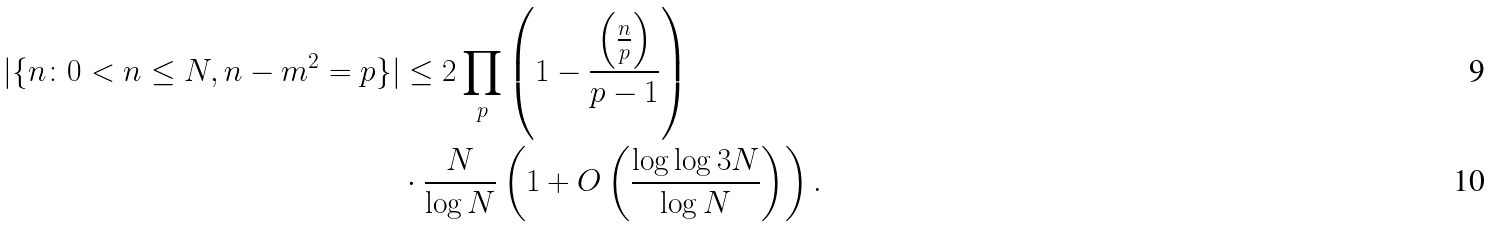Convert formula to latex. <formula><loc_0><loc_0><loc_500><loc_500>| \{ n \colon 0 < n \leq N , n - m ^ { 2 } = p \} | & \leq 2 \prod _ { p } \left ( 1 - \frac { \left ( \frac { n } { p } \right ) } { p - 1 } \right ) \\ & \cdot \frac { N } { \log N } \left ( 1 + O \left ( \frac { \log \log 3 N } { \log N } \right ) \right ) .</formula> 